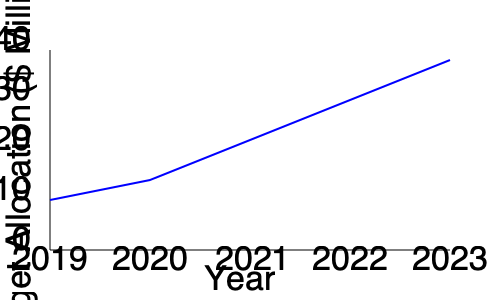Based on the line graph showing the town's budget allocation over the past 5 years, what is the average annual increase in budget allocation from 2019 to 2023? To calculate the average annual increase in budget allocation:

1. Determine the budget values for 2019 and 2023:
   2019: $10 million
   2023: $38 million

2. Calculate the total increase:
   $38 million - $10 million = $28 million

3. Divide the total increase by the number of years (5-1 = 4) to get the average annual increase:
   $28 million ÷ 4 = $7 million

Therefore, the average annual increase in budget allocation from 2019 to 2023 is $7 million.
Answer: $7 million per year 